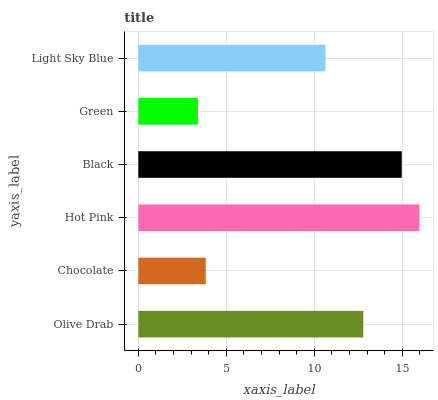Is Green the minimum?
Answer yes or no. Yes. Is Hot Pink the maximum?
Answer yes or no. Yes. Is Chocolate the minimum?
Answer yes or no. No. Is Chocolate the maximum?
Answer yes or no. No. Is Olive Drab greater than Chocolate?
Answer yes or no. Yes. Is Chocolate less than Olive Drab?
Answer yes or no. Yes. Is Chocolate greater than Olive Drab?
Answer yes or no. No. Is Olive Drab less than Chocolate?
Answer yes or no. No. Is Olive Drab the high median?
Answer yes or no. Yes. Is Light Sky Blue the low median?
Answer yes or no. Yes. Is Chocolate the high median?
Answer yes or no. No. Is Green the low median?
Answer yes or no. No. 